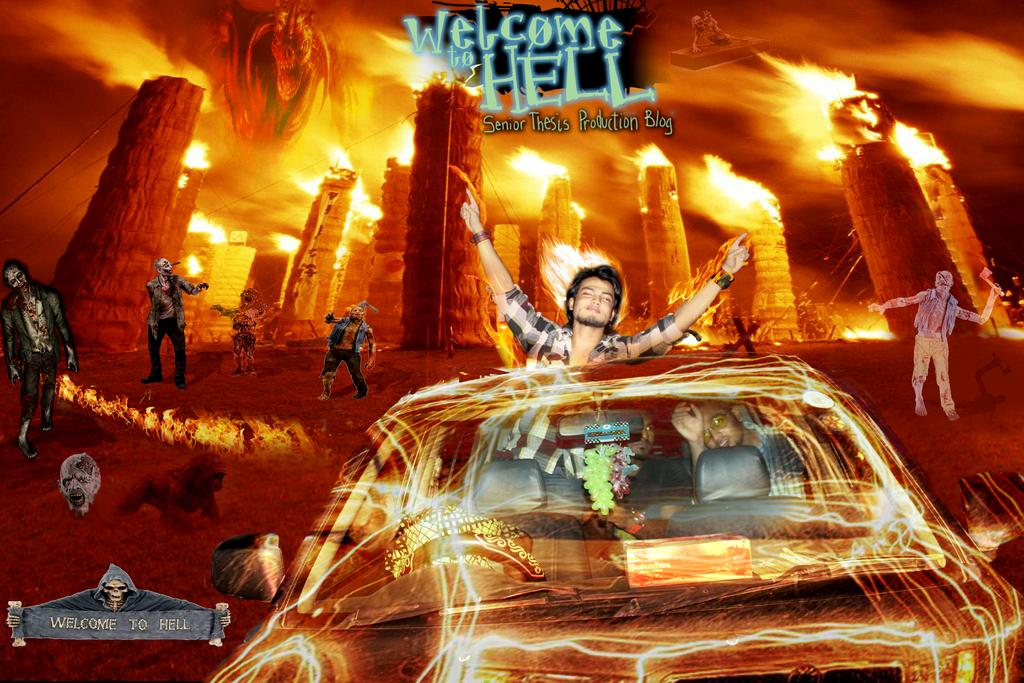<image>
Give a short and clear explanation of the subsequent image. A poster of two guys driving through fire and the sign says Welcome to Hell. 